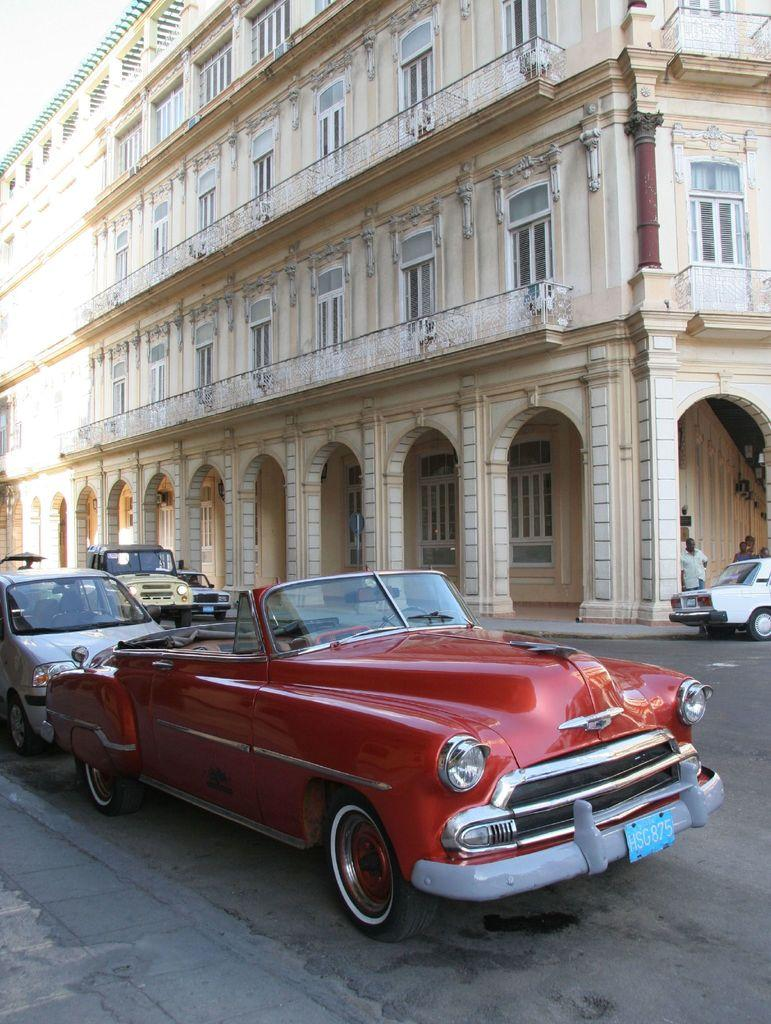What can be seen on the road in the image? There are vehicles on the road in the image. What are the people near the car doing? The people standing near a car in the image are not performing any specific action that can be determined from the facts provided. What is visible in the background of the image? There is a building visible in the background of the image. What type of clouds can be seen in the image? There is no mention of clouds in the provided facts, so it cannot be determined if any are present in the image. What is the value of the car in the image? The value of the car cannot be determined from the image alone, as it requires additional information such as the make, model, and condition of the vehicle. 